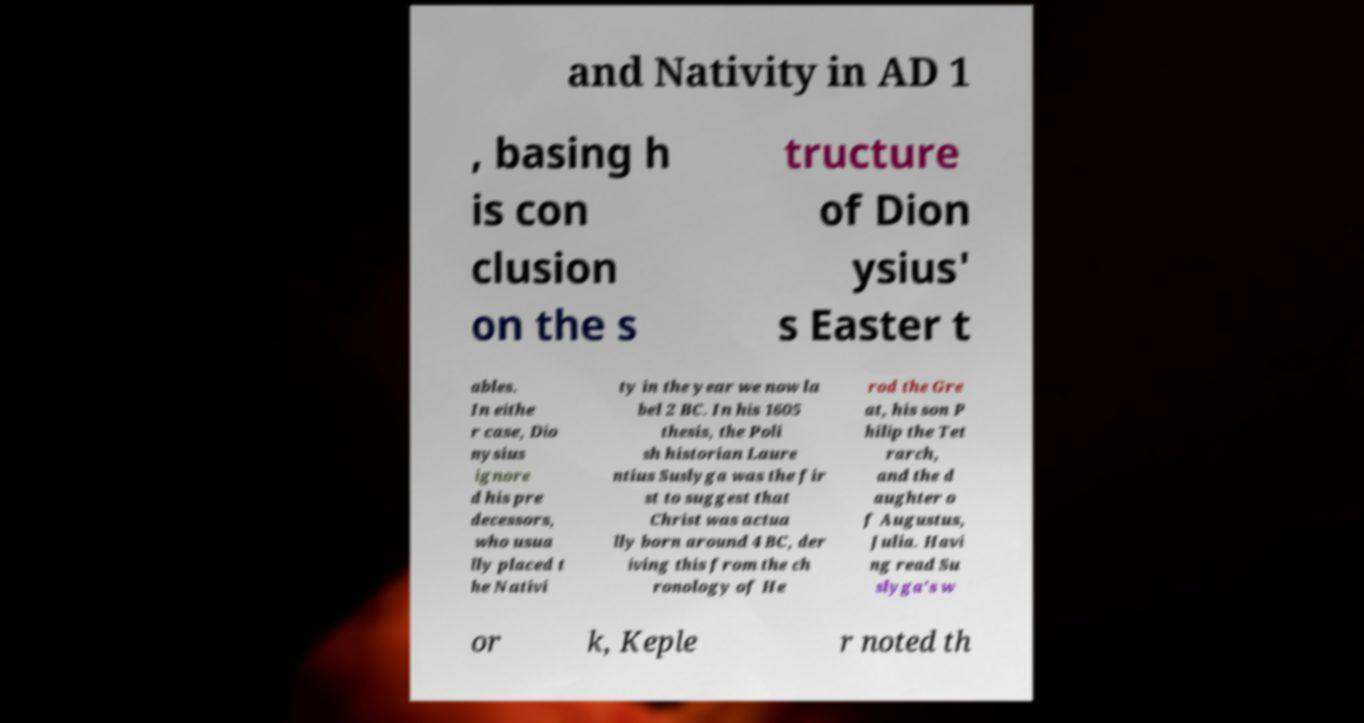Can you accurately transcribe the text from the provided image for me? and Nativity in AD 1 , basing h is con clusion on the s tructure of Dion ysius' s Easter t ables. In eithe r case, Dio nysius ignore d his pre decessors, who usua lly placed t he Nativi ty in the year we now la bel 2 BC. In his 1605 thesis, the Poli sh historian Laure ntius Suslyga was the fir st to suggest that Christ was actua lly born around 4 BC, der iving this from the ch ronology of He rod the Gre at, his son P hilip the Tet rarch, and the d aughter o f Augustus, Julia. Havi ng read Su slyga's w or k, Keple r noted th 